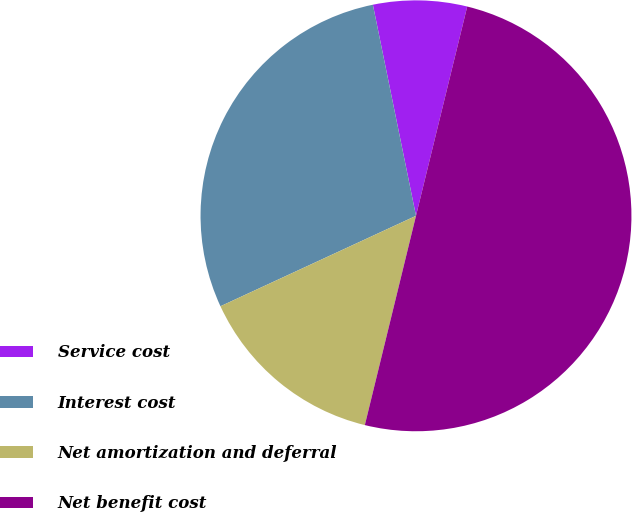<chart> <loc_0><loc_0><loc_500><loc_500><pie_chart><fcel>Service cost<fcel>Interest cost<fcel>Net amortization and deferral<fcel>Net benefit cost<nl><fcel>7.03%<fcel>28.69%<fcel>14.29%<fcel>50.0%<nl></chart> 